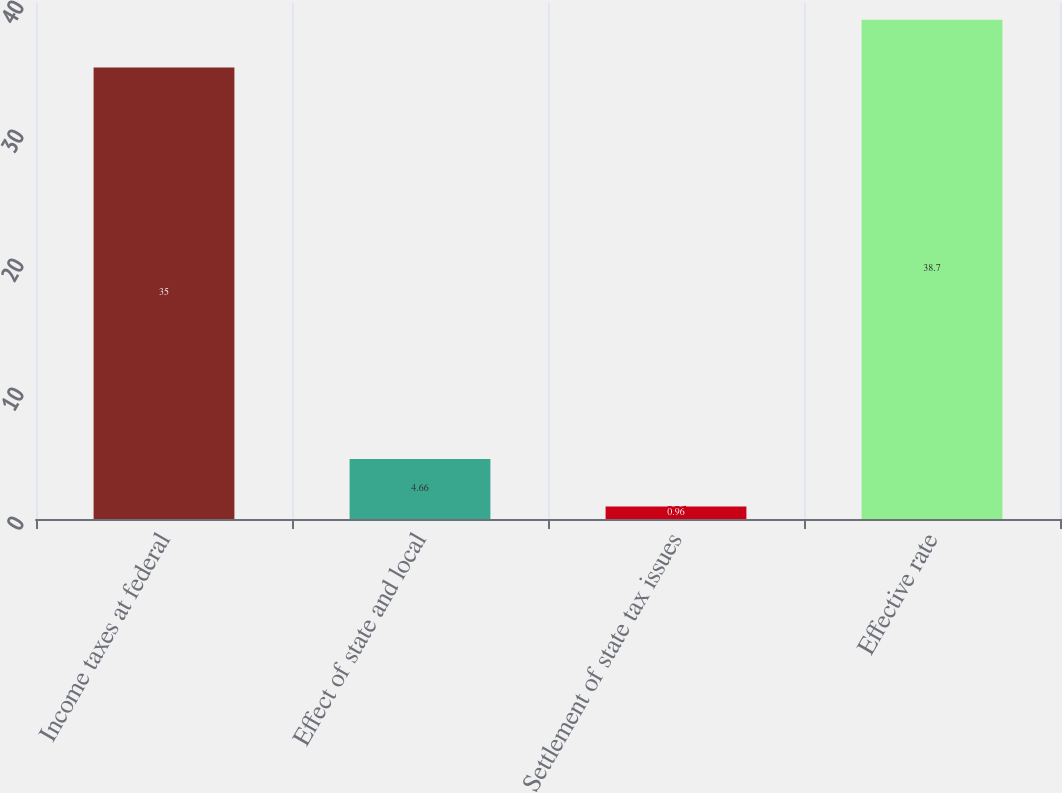<chart> <loc_0><loc_0><loc_500><loc_500><bar_chart><fcel>Income taxes at federal<fcel>Effect of state and local<fcel>Settlement of state tax issues<fcel>Effective rate<nl><fcel>35<fcel>4.66<fcel>0.96<fcel>38.7<nl></chart> 